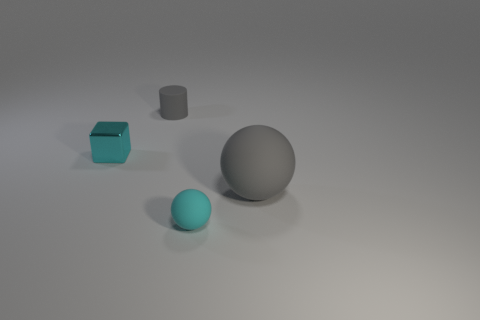Is the shape of the large gray object the same as the small cyan rubber thing?
Provide a short and direct response. Yes. There is a object that is to the left of the big gray object and right of the tiny gray cylinder; what color is it?
Offer a very short reply. Cyan. What size is the matte ball that is the same color as the tiny cube?
Make the answer very short. Small. How many small objects are matte balls or metallic blocks?
Offer a terse response. 2. Is there anything else of the same color as the big ball?
Offer a very short reply. Yes. What is the material of the thing to the left of the small matte thing behind the cyan thing that is right of the tiny matte cylinder?
Offer a very short reply. Metal. How many matte things are small cyan cubes or spheres?
Make the answer very short. 2. What number of green objects are matte balls or small objects?
Ensure brevity in your answer.  0. There is a small matte object that is behind the cyan block; is it the same color as the big object?
Your answer should be very brief. Yes. Are the large gray sphere and the small sphere made of the same material?
Give a very brief answer. Yes. 